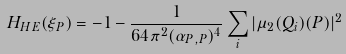Convert formula to latex. <formula><loc_0><loc_0><loc_500><loc_500>H _ { H E } ( \xi _ { P } ) = - 1 - \frac { 1 } { 6 4 { \pi } ^ { 2 } ( \alpha _ { P , P } ) ^ { 4 } } \sum _ { i } | \mu _ { 2 } ( Q _ { i } ) ( P ) | ^ { 2 }</formula> 